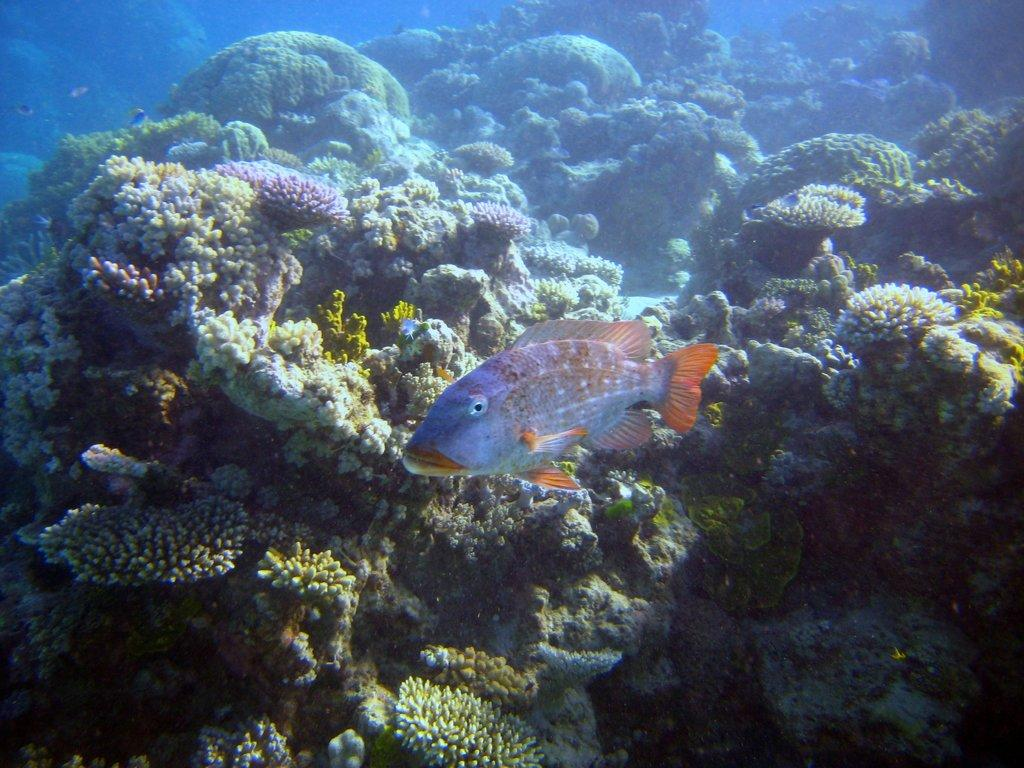What type of animal is in the image? There is a fish in the image. Where is the fish located? The fish is in the water. What else can be seen in the image besides the fish? There are marine organisms visible in the background of the image. What type of respect can be seen in the image? There is no indication of respect in the image; it features a fish in the water and marine organisms in the background. 